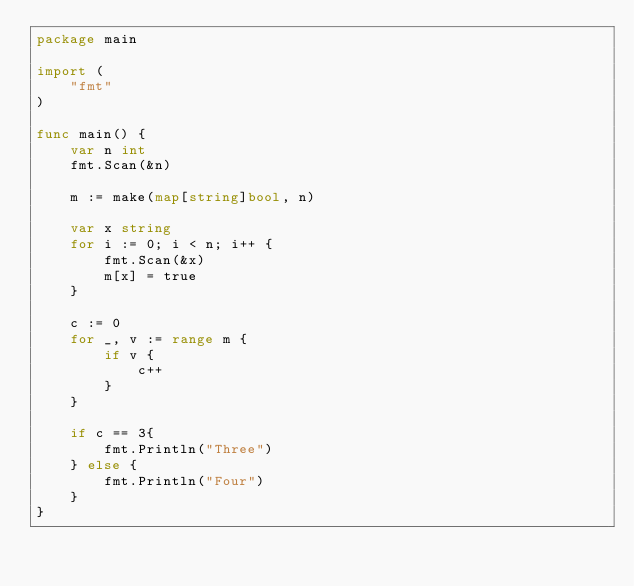<code> <loc_0><loc_0><loc_500><loc_500><_Go_>package main

import (
	"fmt"
)

func main() {
	var n int
	fmt.Scan(&n)

	m := make(map[string]bool, n)

	var x string
	for i := 0; i < n; i++ {
		fmt.Scan(&x)
		m[x] = true
	}

	c := 0
	for _, v := range m {
		if v {
			c++
		}
	}

	if c == 3{
		fmt.Println("Three")
	} else {
		fmt.Println("Four")
	}
}
</code> 